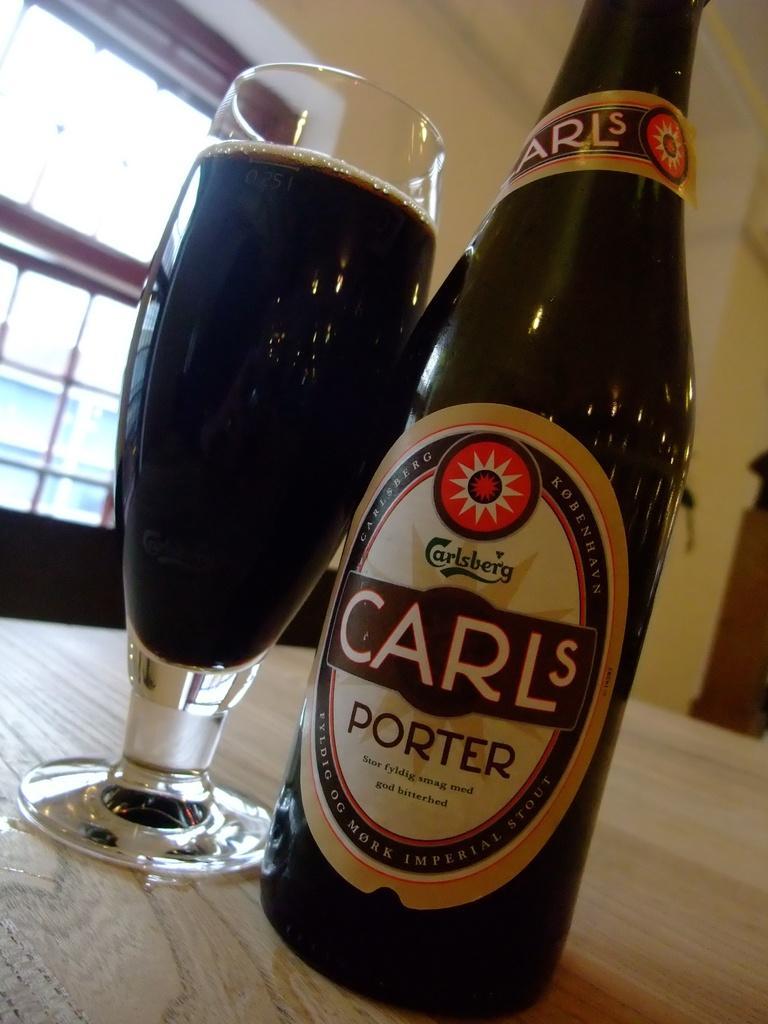How would you summarize this image in a sentence or two? In this image we can see a glass and a bottle on a wooden surface. In the glass we can see the drink and on the bottle we can see a label. On the label we can see the text. Behind the bottle we can see a window and a wall. 